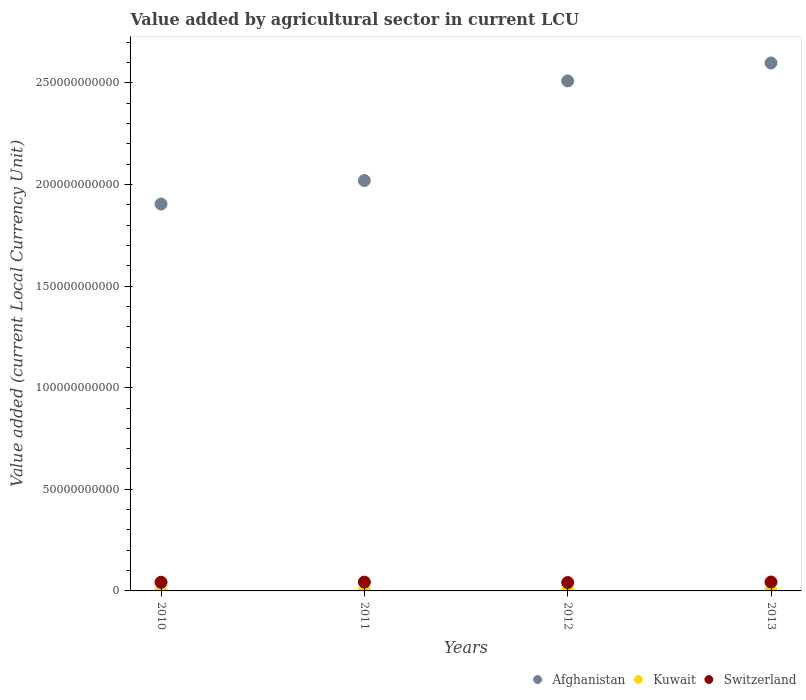How many different coloured dotlines are there?
Offer a very short reply. 3. Is the number of dotlines equal to the number of legend labels?
Your response must be concise. Yes. What is the value added by agricultural sector in Switzerland in 2010?
Your answer should be compact. 4.26e+09. Across all years, what is the maximum value added by agricultural sector in Switzerland?
Your response must be concise. 4.37e+09. Across all years, what is the minimum value added by agricultural sector in Afghanistan?
Your answer should be very brief. 1.90e+11. In which year was the value added by agricultural sector in Kuwait minimum?
Your answer should be compact. 2010. What is the total value added by agricultural sector in Kuwait in the graph?
Provide a short and direct response. 6.87e+08. What is the difference between the value added by agricultural sector in Switzerland in 2011 and that in 2012?
Provide a succinct answer. 2.05e+08. What is the difference between the value added by agricultural sector in Kuwait in 2011 and the value added by agricultural sector in Switzerland in 2010?
Ensure brevity in your answer.  -4.07e+09. What is the average value added by agricultural sector in Kuwait per year?
Your answer should be very brief. 1.72e+08. In the year 2010, what is the difference between the value added by agricultural sector in Kuwait and value added by agricultural sector in Afghanistan?
Your answer should be compact. -1.90e+11. What is the ratio of the value added by agricultural sector in Switzerland in 2010 to that in 2012?
Your response must be concise. 1.03. Is the value added by agricultural sector in Afghanistan in 2011 less than that in 2013?
Offer a very short reply. Yes. Is the difference between the value added by agricultural sector in Kuwait in 2011 and 2013 greater than the difference between the value added by agricultural sector in Afghanistan in 2011 and 2013?
Ensure brevity in your answer.  Yes. What is the difference between the highest and the second highest value added by agricultural sector in Kuwait?
Your response must be concise. 1.12e+07. What is the difference between the highest and the lowest value added by agricultural sector in Kuwait?
Your answer should be compact. 3.72e+07. In how many years, is the value added by agricultural sector in Kuwait greater than the average value added by agricultural sector in Kuwait taken over all years?
Offer a terse response. 3. Is the value added by agricultural sector in Kuwait strictly less than the value added by agricultural sector in Switzerland over the years?
Your response must be concise. Yes. How many years are there in the graph?
Make the answer very short. 4. Where does the legend appear in the graph?
Provide a short and direct response. Bottom right. How many legend labels are there?
Ensure brevity in your answer.  3. How are the legend labels stacked?
Your response must be concise. Horizontal. What is the title of the graph?
Ensure brevity in your answer.  Value added by agricultural sector in current LCU. What is the label or title of the Y-axis?
Offer a terse response. Value added (current Local Currency Unit). What is the Value added (current Local Currency Unit) of Afghanistan in 2010?
Offer a terse response. 1.90e+11. What is the Value added (current Local Currency Unit) in Kuwait in 2010?
Your answer should be compact. 1.49e+08. What is the Value added (current Local Currency Unit) in Switzerland in 2010?
Provide a succinct answer. 4.26e+09. What is the Value added (current Local Currency Unit) in Afghanistan in 2011?
Your response must be concise. 2.02e+11. What is the Value added (current Local Currency Unit) in Kuwait in 2011?
Keep it short and to the point. 1.87e+08. What is the Value added (current Local Currency Unit) in Switzerland in 2011?
Provide a short and direct response. 4.33e+09. What is the Value added (current Local Currency Unit) of Afghanistan in 2012?
Offer a terse response. 2.51e+11. What is the Value added (current Local Currency Unit) of Kuwait in 2012?
Your response must be concise. 1.75e+08. What is the Value added (current Local Currency Unit) of Switzerland in 2012?
Provide a succinct answer. 4.13e+09. What is the Value added (current Local Currency Unit) in Afghanistan in 2013?
Keep it short and to the point. 2.60e+11. What is the Value added (current Local Currency Unit) of Kuwait in 2013?
Give a very brief answer. 1.75e+08. What is the Value added (current Local Currency Unit) in Switzerland in 2013?
Your response must be concise. 4.37e+09. Across all years, what is the maximum Value added (current Local Currency Unit) of Afghanistan?
Your answer should be compact. 2.60e+11. Across all years, what is the maximum Value added (current Local Currency Unit) in Kuwait?
Keep it short and to the point. 1.87e+08. Across all years, what is the maximum Value added (current Local Currency Unit) in Switzerland?
Provide a succinct answer. 4.37e+09. Across all years, what is the minimum Value added (current Local Currency Unit) of Afghanistan?
Keep it short and to the point. 1.90e+11. Across all years, what is the minimum Value added (current Local Currency Unit) of Kuwait?
Give a very brief answer. 1.49e+08. Across all years, what is the minimum Value added (current Local Currency Unit) in Switzerland?
Provide a succinct answer. 4.13e+09. What is the total Value added (current Local Currency Unit) in Afghanistan in the graph?
Give a very brief answer. 9.03e+11. What is the total Value added (current Local Currency Unit) of Kuwait in the graph?
Keep it short and to the point. 6.87e+08. What is the total Value added (current Local Currency Unit) in Switzerland in the graph?
Offer a terse response. 1.71e+1. What is the difference between the Value added (current Local Currency Unit) of Afghanistan in 2010 and that in 2011?
Provide a short and direct response. -1.16e+1. What is the difference between the Value added (current Local Currency Unit) of Kuwait in 2010 and that in 2011?
Ensure brevity in your answer.  -3.72e+07. What is the difference between the Value added (current Local Currency Unit) of Switzerland in 2010 and that in 2011?
Keep it short and to the point. -7.56e+07. What is the difference between the Value added (current Local Currency Unit) of Afghanistan in 2010 and that in 2012?
Your answer should be compact. -6.06e+1. What is the difference between the Value added (current Local Currency Unit) of Kuwait in 2010 and that in 2012?
Your answer should be compact. -2.59e+07. What is the difference between the Value added (current Local Currency Unit) of Switzerland in 2010 and that in 2012?
Keep it short and to the point. 1.29e+08. What is the difference between the Value added (current Local Currency Unit) of Afghanistan in 2010 and that in 2013?
Ensure brevity in your answer.  -6.94e+1. What is the difference between the Value added (current Local Currency Unit) in Kuwait in 2010 and that in 2013?
Provide a short and direct response. -2.60e+07. What is the difference between the Value added (current Local Currency Unit) of Switzerland in 2010 and that in 2013?
Keep it short and to the point. -1.13e+08. What is the difference between the Value added (current Local Currency Unit) in Afghanistan in 2011 and that in 2012?
Your answer should be very brief. -4.90e+1. What is the difference between the Value added (current Local Currency Unit) in Kuwait in 2011 and that in 2012?
Keep it short and to the point. 1.13e+07. What is the difference between the Value added (current Local Currency Unit) in Switzerland in 2011 and that in 2012?
Give a very brief answer. 2.05e+08. What is the difference between the Value added (current Local Currency Unit) of Afghanistan in 2011 and that in 2013?
Offer a very short reply. -5.79e+1. What is the difference between the Value added (current Local Currency Unit) of Kuwait in 2011 and that in 2013?
Offer a very short reply. 1.12e+07. What is the difference between the Value added (current Local Currency Unit) in Switzerland in 2011 and that in 2013?
Offer a very short reply. -3.70e+07. What is the difference between the Value added (current Local Currency Unit) in Afghanistan in 2012 and that in 2013?
Ensure brevity in your answer.  -8.84e+09. What is the difference between the Value added (current Local Currency Unit) in Kuwait in 2012 and that in 2013?
Ensure brevity in your answer.  -1.00e+05. What is the difference between the Value added (current Local Currency Unit) of Switzerland in 2012 and that in 2013?
Offer a terse response. -2.42e+08. What is the difference between the Value added (current Local Currency Unit) of Afghanistan in 2010 and the Value added (current Local Currency Unit) of Kuwait in 2011?
Make the answer very short. 1.90e+11. What is the difference between the Value added (current Local Currency Unit) of Afghanistan in 2010 and the Value added (current Local Currency Unit) of Switzerland in 2011?
Make the answer very short. 1.86e+11. What is the difference between the Value added (current Local Currency Unit) in Kuwait in 2010 and the Value added (current Local Currency Unit) in Switzerland in 2011?
Make the answer very short. -4.18e+09. What is the difference between the Value added (current Local Currency Unit) in Afghanistan in 2010 and the Value added (current Local Currency Unit) in Kuwait in 2012?
Provide a short and direct response. 1.90e+11. What is the difference between the Value added (current Local Currency Unit) in Afghanistan in 2010 and the Value added (current Local Currency Unit) in Switzerland in 2012?
Your answer should be very brief. 1.86e+11. What is the difference between the Value added (current Local Currency Unit) of Kuwait in 2010 and the Value added (current Local Currency Unit) of Switzerland in 2012?
Offer a very short reply. -3.98e+09. What is the difference between the Value added (current Local Currency Unit) in Afghanistan in 2010 and the Value added (current Local Currency Unit) in Kuwait in 2013?
Provide a succinct answer. 1.90e+11. What is the difference between the Value added (current Local Currency Unit) in Afghanistan in 2010 and the Value added (current Local Currency Unit) in Switzerland in 2013?
Make the answer very short. 1.86e+11. What is the difference between the Value added (current Local Currency Unit) in Kuwait in 2010 and the Value added (current Local Currency Unit) in Switzerland in 2013?
Provide a succinct answer. -4.22e+09. What is the difference between the Value added (current Local Currency Unit) of Afghanistan in 2011 and the Value added (current Local Currency Unit) of Kuwait in 2012?
Provide a succinct answer. 2.02e+11. What is the difference between the Value added (current Local Currency Unit) of Afghanistan in 2011 and the Value added (current Local Currency Unit) of Switzerland in 2012?
Offer a terse response. 1.98e+11. What is the difference between the Value added (current Local Currency Unit) of Kuwait in 2011 and the Value added (current Local Currency Unit) of Switzerland in 2012?
Provide a succinct answer. -3.94e+09. What is the difference between the Value added (current Local Currency Unit) of Afghanistan in 2011 and the Value added (current Local Currency Unit) of Kuwait in 2013?
Offer a terse response. 2.02e+11. What is the difference between the Value added (current Local Currency Unit) of Afghanistan in 2011 and the Value added (current Local Currency Unit) of Switzerland in 2013?
Provide a succinct answer. 1.98e+11. What is the difference between the Value added (current Local Currency Unit) of Kuwait in 2011 and the Value added (current Local Currency Unit) of Switzerland in 2013?
Your response must be concise. -4.18e+09. What is the difference between the Value added (current Local Currency Unit) of Afghanistan in 2012 and the Value added (current Local Currency Unit) of Kuwait in 2013?
Keep it short and to the point. 2.51e+11. What is the difference between the Value added (current Local Currency Unit) of Afghanistan in 2012 and the Value added (current Local Currency Unit) of Switzerland in 2013?
Ensure brevity in your answer.  2.47e+11. What is the difference between the Value added (current Local Currency Unit) of Kuwait in 2012 and the Value added (current Local Currency Unit) of Switzerland in 2013?
Your answer should be very brief. -4.19e+09. What is the average Value added (current Local Currency Unit) in Afghanistan per year?
Give a very brief answer. 2.26e+11. What is the average Value added (current Local Currency Unit) in Kuwait per year?
Keep it short and to the point. 1.72e+08. What is the average Value added (current Local Currency Unit) of Switzerland per year?
Ensure brevity in your answer.  4.27e+09. In the year 2010, what is the difference between the Value added (current Local Currency Unit) of Afghanistan and Value added (current Local Currency Unit) of Kuwait?
Make the answer very short. 1.90e+11. In the year 2010, what is the difference between the Value added (current Local Currency Unit) of Afghanistan and Value added (current Local Currency Unit) of Switzerland?
Provide a succinct answer. 1.86e+11. In the year 2010, what is the difference between the Value added (current Local Currency Unit) in Kuwait and Value added (current Local Currency Unit) in Switzerland?
Ensure brevity in your answer.  -4.11e+09. In the year 2011, what is the difference between the Value added (current Local Currency Unit) in Afghanistan and Value added (current Local Currency Unit) in Kuwait?
Provide a succinct answer. 2.02e+11. In the year 2011, what is the difference between the Value added (current Local Currency Unit) in Afghanistan and Value added (current Local Currency Unit) in Switzerland?
Your answer should be very brief. 1.98e+11. In the year 2011, what is the difference between the Value added (current Local Currency Unit) of Kuwait and Value added (current Local Currency Unit) of Switzerland?
Provide a short and direct response. -4.15e+09. In the year 2012, what is the difference between the Value added (current Local Currency Unit) in Afghanistan and Value added (current Local Currency Unit) in Kuwait?
Your response must be concise. 2.51e+11. In the year 2012, what is the difference between the Value added (current Local Currency Unit) in Afghanistan and Value added (current Local Currency Unit) in Switzerland?
Make the answer very short. 2.47e+11. In the year 2012, what is the difference between the Value added (current Local Currency Unit) in Kuwait and Value added (current Local Currency Unit) in Switzerland?
Offer a terse response. -3.95e+09. In the year 2013, what is the difference between the Value added (current Local Currency Unit) in Afghanistan and Value added (current Local Currency Unit) in Kuwait?
Your answer should be very brief. 2.60e+11. In the year 2013, what is the difference between the Value added (current Local Currency Unit) of Afghanistan and Value added (current Local Currency Unit) of Switzerland?
Your response must be concise. 2.55e+11. In the year 2013, what is the difference between the Value added (current Local Currency Unit) in Kuwait and Value added (current Local Currency Unit) in Switzerland?
Offer a terse response. -4.19e+09. What is the ratio of the Value added (current Local Currency Unit) in Afghanistan in 2010 to that in 2011?
Make the answer very short. 0.94. What is the ratio of the Value added (current Local Currency Unit) in Kuwait in 2010 to that in 2011?
Offer a very short reply. 0.8. What is the ratio of the Value added (current Local Currency Unit) in Switzerland in 2010 to that in 2011?
Your response must be concise. 0.98. What is the ratio of the Value added (current Local Currency Unit) of Afghanistan in 2010 to that in 2012?
Ensure brevity in your answer.  0.76. What is the ratio of the Value added (current Local Currency Unit) in Kuwait in 2010 to that in 2012?
Your answer should be compact. 0.85. What is the ratio of the Value added (current Local Currency Unit) in Switzerland in 2010 to that in 2012?
Give a very brief answer. 1.03. What is the ratio of the Value added (current Local Currency Unit) of Afghanistan in 2010 to that in 2013?
Keep it short and to the point. 0.73. What is the ratio of the Value added (current Local Currency Unit) of Kuwait in 2010 to that in 2013?
Your response must be concise. 0.85. What is the ratio of the Value added (current Local Currency Unit) of Switzerland in 2010 to that in 2013?
Provide a succinct answer. 0.97. What is the ratio of the Value added (current Local Currency Unit) of Afghanistan in 2011 to that in 2012?
Provide a short and direct response. 0.8. What is the ratio of the Value added (current Local Currency Unit) in Kuwait in 2011 to that in 2012?
Provide a succinct answer. 1.06. What is the ratio of the Value added (current Local Currency Unit) of Switzerland in 2011 to that in 2012?
Provide a short and direct response. 1.05. What is the ratio of the Value added (current Local Currency Unit) in Afghanistan in 2011 to that in 2013?
Provide a short and direct response. 0.78. What is the ratio of the Value added (current Local Currency Unit) in Kuwait in 2011 to that in 2013?
Offer a terse response. 1.06. What is the ratio of the Value added (current Local Currency Unit) of Switzerland in 2011 to that in 2013?
Ensure brevity in your answer.  0.99. What is the ratio of the Value added (current Local Currency Unit) of Afghanistan in 2012 to that in 2013?
Ensure brevity in your answer.  0.97. What is the ratio of the Value added (current Local Currency Unit) of Switzerland in 2012 to that in 2013?
Offer a very short reply. 0.94. What is the difference between the highest and the second highest Value added (current Local Currency Unit) of Afghanistan?
Provide a short and direct response. 8.84e+09. What is the difference between the highest and the second highest Value added (current Local Currency Unit) in Kuwait?
Offer a terse response. 1.12e+07. What is the difference between the highest and the second highest Value added (current Local Currency Unit) in Switzerland?
Give a very brief answer. 3.70e+07. What is the difference between the highest and the lowest Value added (current Local Currency Unit) of Afghanistan?
Offer a terse response. 6.94e+1. What is the difference between the highest and the lowest Value added (current Local Currency Unit) in Kuwait?
Give a very brief answer. 3.72e+07. What is the difference between the highest and the lowest Value added (current Local Currency Unit) in Switzerland?
Make the answer very short. 2.42e+08. 